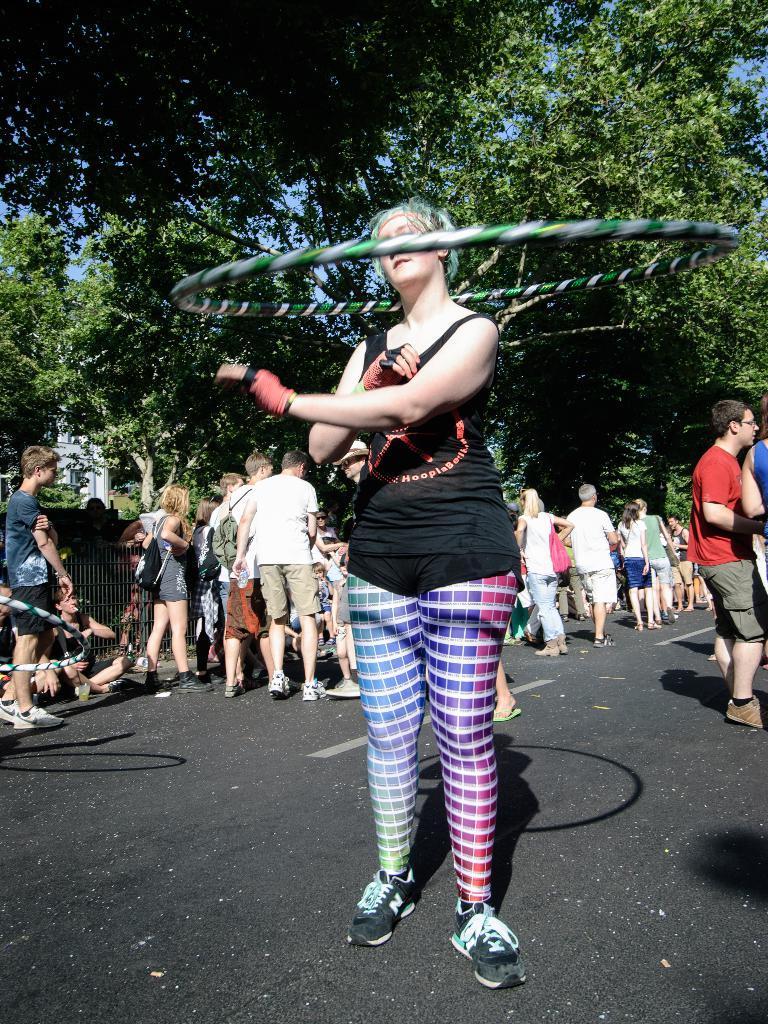Describe this image in one or two sentences. This picture is clicked outside. In the center there is a woman wearing black color t-shirt and standing on the ground and we can see the hula hoop is in the air. In the background we can see the group of persons seems to be walking on the ground and we can see the trees and the sky. 